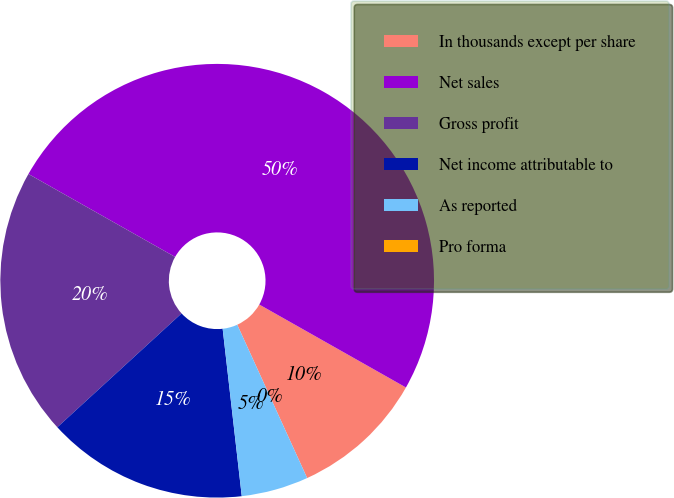Convert chart to OTSL. <chart><loc_0><loc_0><loc_500><loc_500><pie_chart><fcel>In thousands except per share<fcel>Net sales<fcel>Gross profit<fcel>Net income attributable to<fcel>As reported<fcel>Pro forma<nl><fcel>10.0%<fcel>50.0%<fcel>20.0%<fcel>15.0%<fcel>5.0%<fcel>0.0%<nl></chart> 